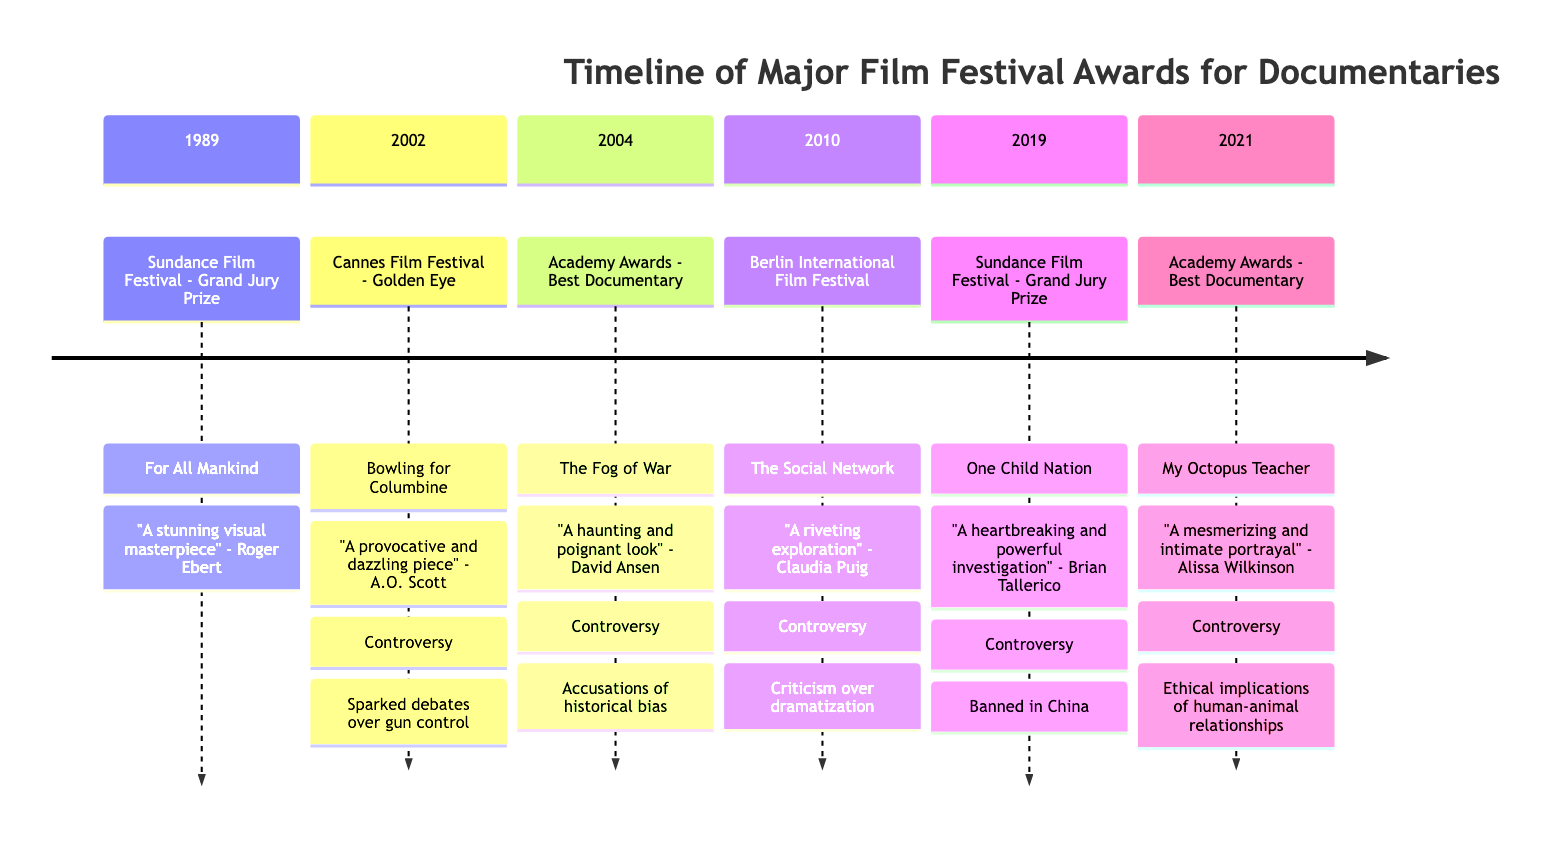What documentary won the Grand Jury Prize at Sundance in 1989? The diagram indicates that "For All Mankind" was the winner for the Grand Jury Prize at Sundance Film Festival in 1989.
Answer: For All Mankind Which year did "Bowling for Columbine" win the Golden Eye at Cannes? The timeline shows that "Bowling for Columbine" won at the Cannes Film Festival in 2002.
Answer: 2002 What was the controversy surrounding "The Fog of War"? The timeline indicates that the controversy for "The Fog of War" involved accusations of historical bias and misrepresentation of Robert S. McNamara.
Answer: Accusations of historical bias Which film received criticism for the dramatization of real events? According to the timeline, "The Social Network" received criticism regarding the dramatization of real events and characters.
Answer: The Social Network How many documentaries won awards between 1989 and 2021 on this timeline? Counting the events listed from 1989 to 2021, there are six documentary winners shown on the timeline.
Answer: 6 What award did "My Octopus Teacher" win in 2021? According to the diagram, "My Octopus Teacher" won the Best Documentary Feature at the Academy Awards in 2021.
Answer: Best Documentary Feature What type of documentary is "One Child Nation" described as? The diagram describes "One Child Nation" as a "heartbreaking and powerful investigation" into China's one-child policy.
Answer: Heartbreaking and powerful investigation Who wrote a review stating, "A mesmerizing and intimate portrayal of nature’s wonders"? The timeline features a review by Alissa Wilkinson, who described "My Octopus Teacher" with that phrase.
Answer: Alissa Wilkinson What is the theme of the controversy linked to "One Child Nation"? The timeline indicates that the controversy involved the film being banned in China, which sparked debates about censorship.
Answer: Banned in China 